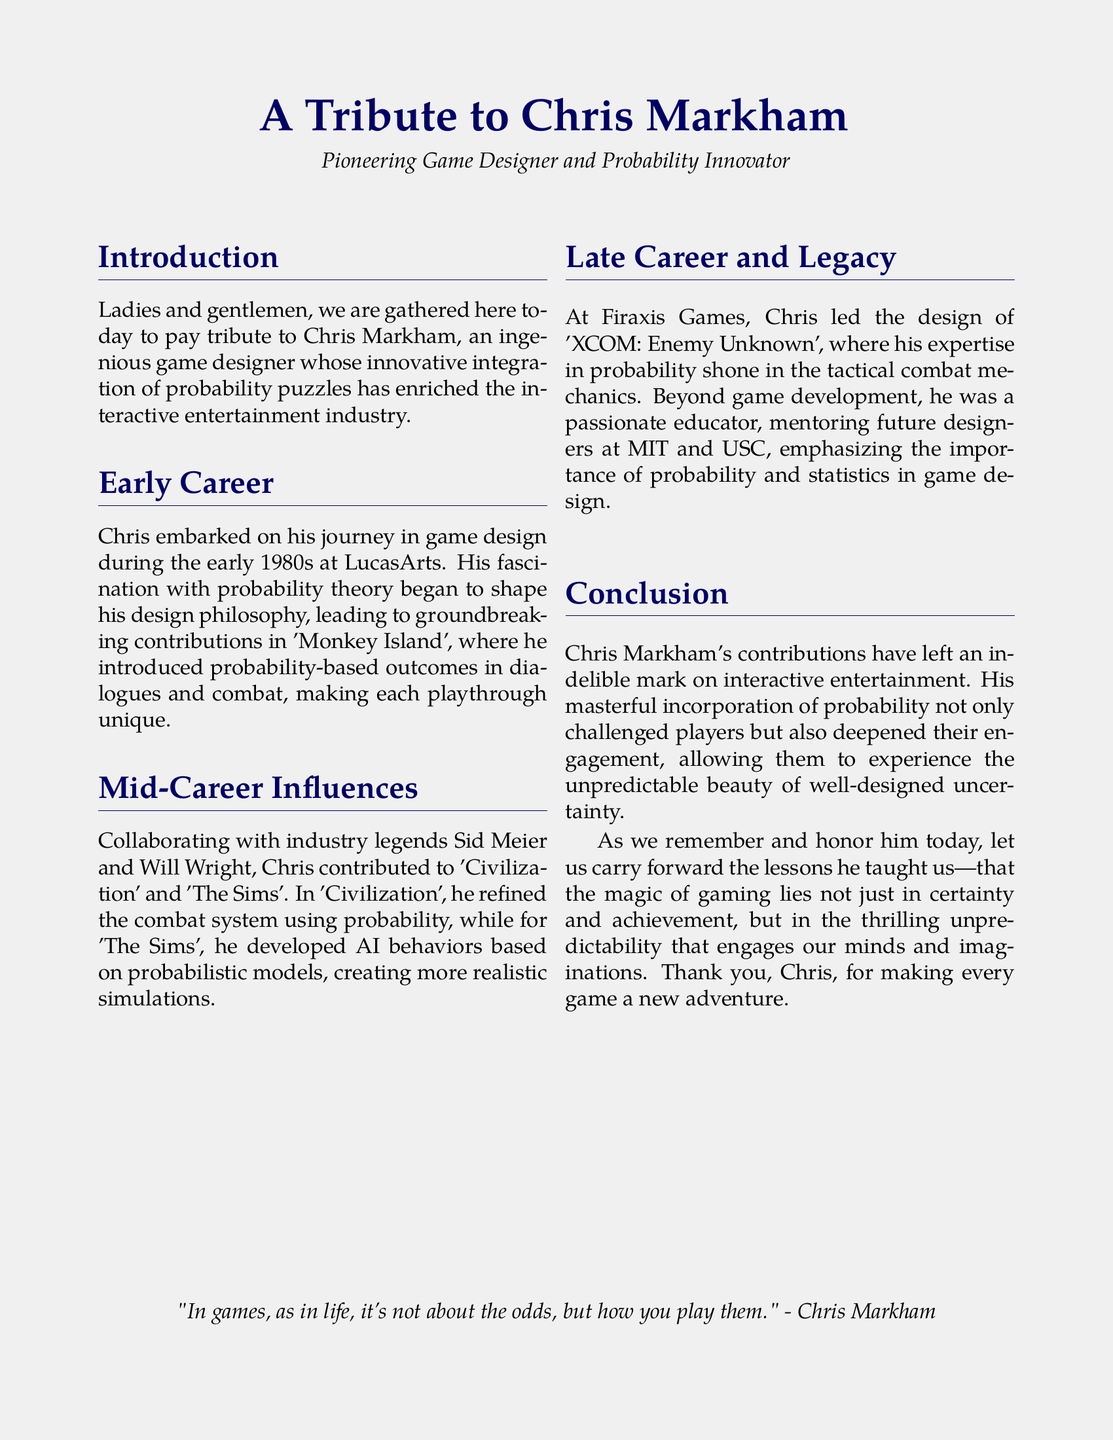What was Chris Markham's profession? The document states that he was a game designer and probability innovator.
Answer: game designer In which decade did Chris begin his career in game design? The introduction mentions that Chris started in the early 1980s.
Answer: 1980s Which game is noted for introducing probability-based outcomes in dialogues? The document highlights 'Monkey Island' for this innovation.
Answer: Monkey Island Who were Chris's collaborators mentioned in the document? The text references Sid Meier and Will Wright as industry legends he collaborated with.
Answer: Sid Meier and Will Wright What was the last game Chris led the design for? The section on late career specifies 'XCOM: Enemy Unknown'.
Answer: XCOM: Enemy Unknown Which institutions did Chris mentor future designers at? The document lists MIT and USC as the institutions where he mentored.
Answer: MIT and USC What philosophy did Chris incorporate into his game design? The document notes that he had a design philosophy shaped by probability theory.
Answer: probability theory What quote from Chris is included in the document? The document features the quote regarding games and odds.
Answer: "In games, as in life, it's not about the odds, but how you play them." How did Chris's work influence player experiences? The conclusion discusses how he deepened engagement through unpredictability.
Answer: unpredictability 